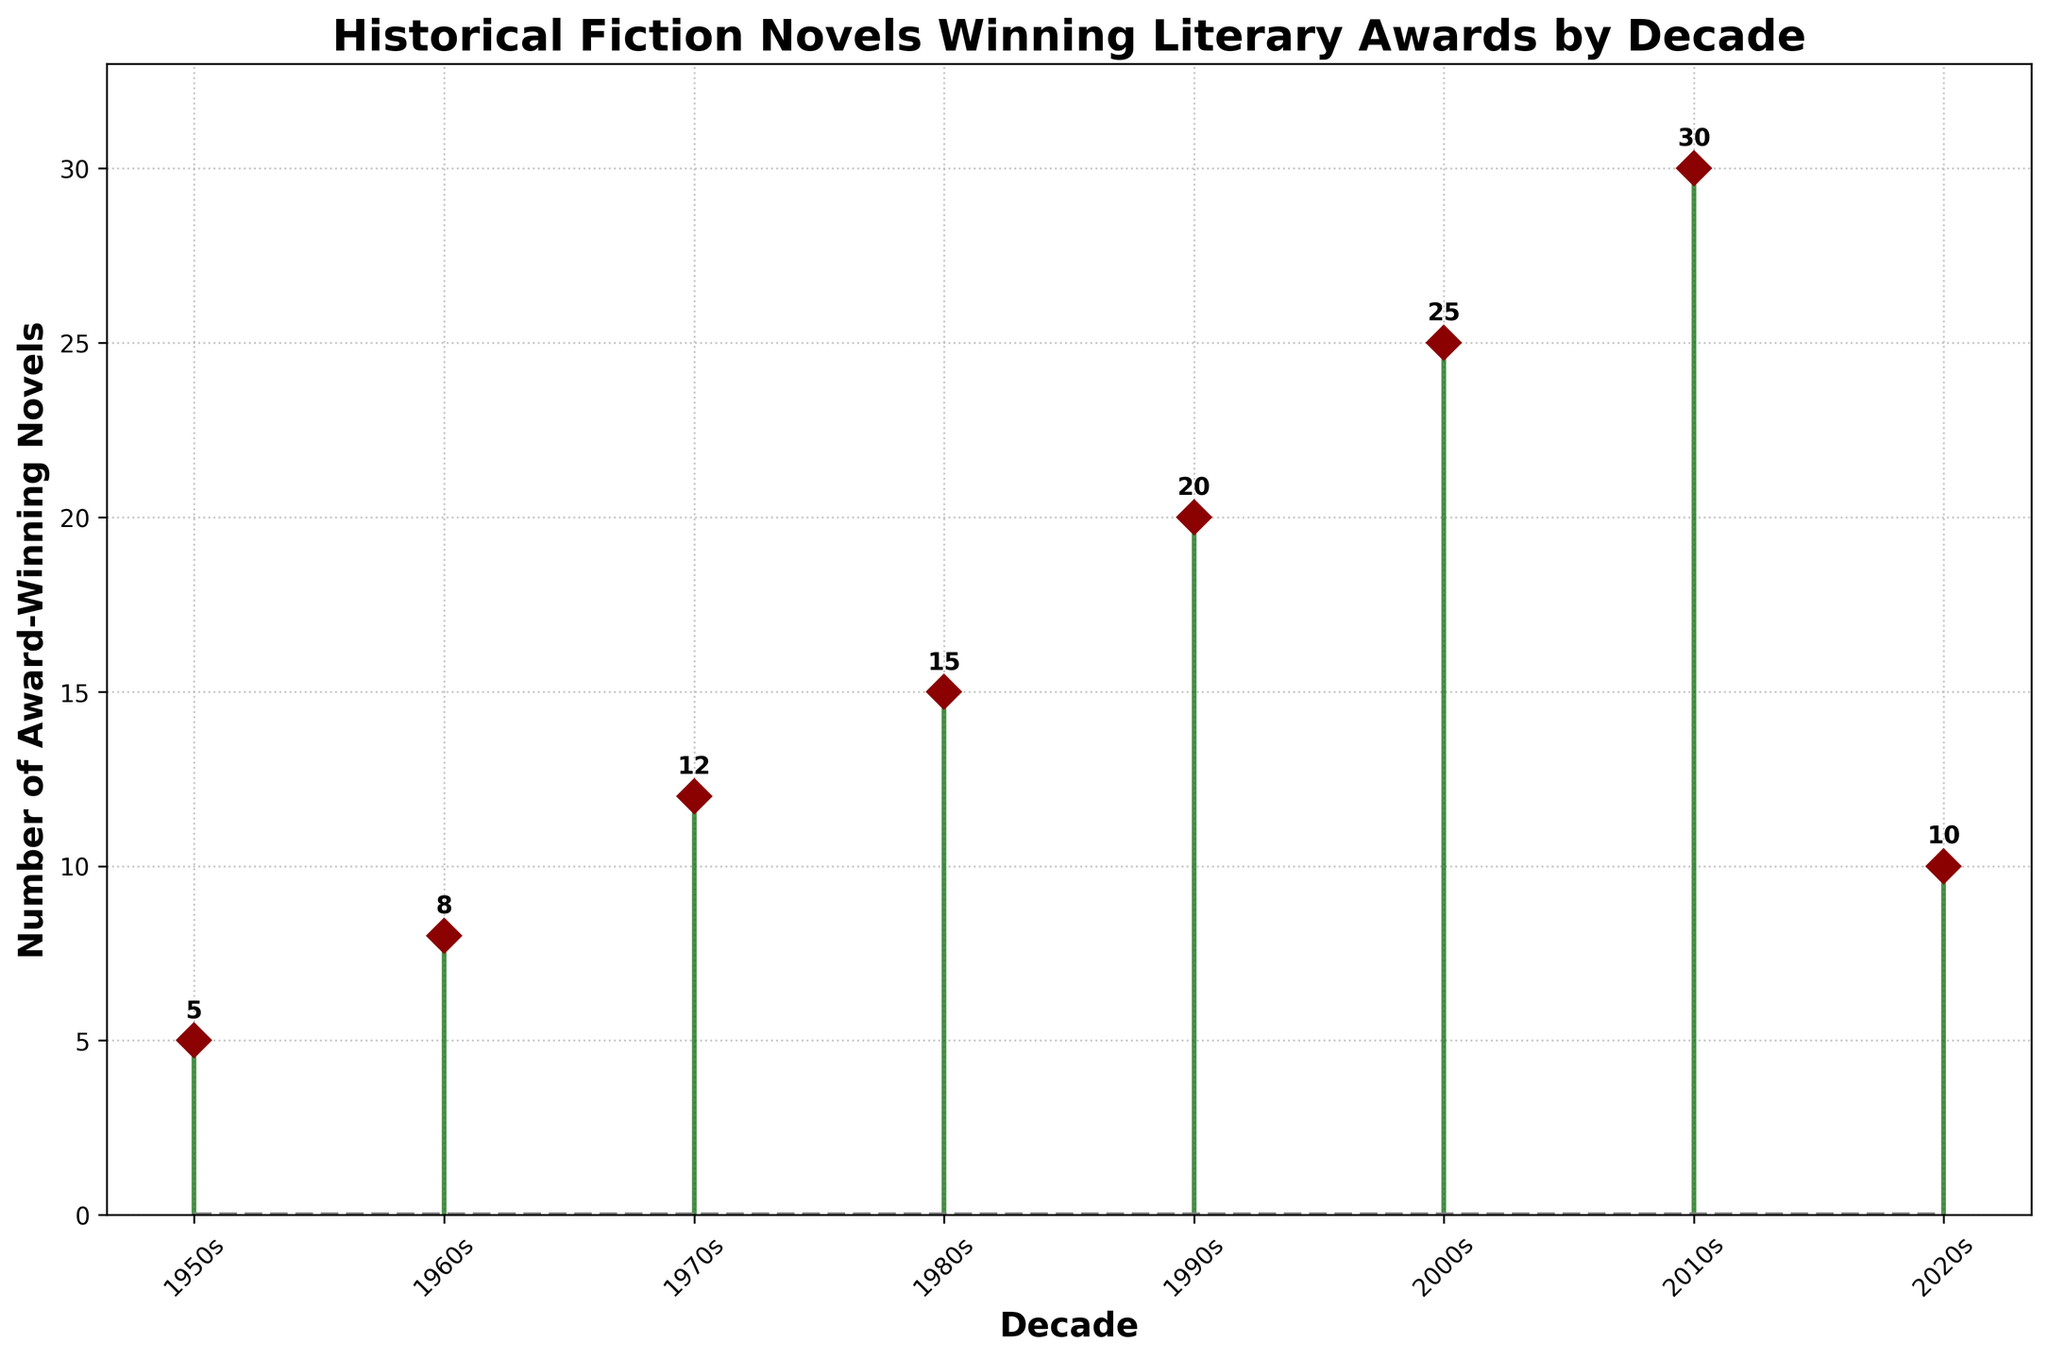What is the title of the figure? The title is usually found at the top of the figure in larger, bold font. In this case, it reads: "Historical Fiction Novels Winning Literary Awards by Decade".
Answer: Historical Fiction Novels Winning Literary Awards by Decade How many award-winning historical fiction novels were there in the 1990s? Locate the data point for the 1990s on the x-axis and read the corresponding value on the y-axis, which is labeled on the plot. It shows 20 novels.
Answer: 20 What decade had the highest number of award-winning novels? Scan the y-axis for the highest value and check the corresponding decade along the x-axis. The highest value is 30, which corresponds to the 2010s.
Answer: 2010s How many more award-winning novels were there in the 1980s compared to the 1950s? Identify the number of novels for the 1980s (15) and the 1950s (5). Subtract the number for the 1950s from the number for the 1980s: 15 - 5 = 10.
Answer: 10 Which two decades experienced the most significant increase or decrease in the number of award-winning novels from the previous decade? Compare the difference between each consecutive data pair. The largest increase (10 novels) occurs between the 2000s (25 novels) and the 2010s (30 novels). The largest decrease (-20 novels) happens between the 2010s (30 novels) and the 2020s (10 novels).
Answer: 2000s-2010s (increase), 2010s-2020s (decrease) What is the median number of award-winning historical fiction novels across all decades? Organize the number of novels in ascending order: 5, 8, 10, 12, 15, 20, 25, 30. Since there are 8 data points, the median is the average of the 4th and 5th numbers: (12+15)/2 = 13.5.
Answer: 13.5 Does the number of award-winning novels ever decrease from one decade to the next? If so, when? Observe the trend from one data point to the next on the stem plot. The number decreases from the 2010s (30 novels) to the 2020s (10 novels).
Answer: Yes, from 2010s to 2020s What is the average number of award-winning novels per decade? Add all the numbers of award-winning novels: 5 + 8 + 12 + 15 + 20 + 25 + 30 + 10 = 125. There are 8 decades, so divide this sum by 8: 125 / 8 ≈ 15.625.
Answer: 15.625 Based on the plot, how is the trend in the number of award-winning novels from the 1950s to the 2010s? Observe the direction and pattern of the data points. There is a general increasing trend from 5 novels in the 1950s to 30 novels in the 2010s.
Answer: Increasing 